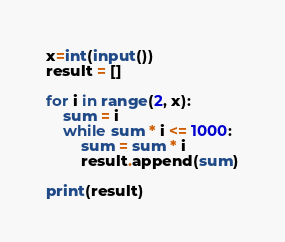Convert code to text. <code><loc_0><loc_0><loc_500><loc_500><_Python_>x=int(input())
result = []

for i in range(2, x):
    sum = i
    while sum * i <= 1000:
        sum = sum * i
        result.append(sum)

print(result)
</code> 